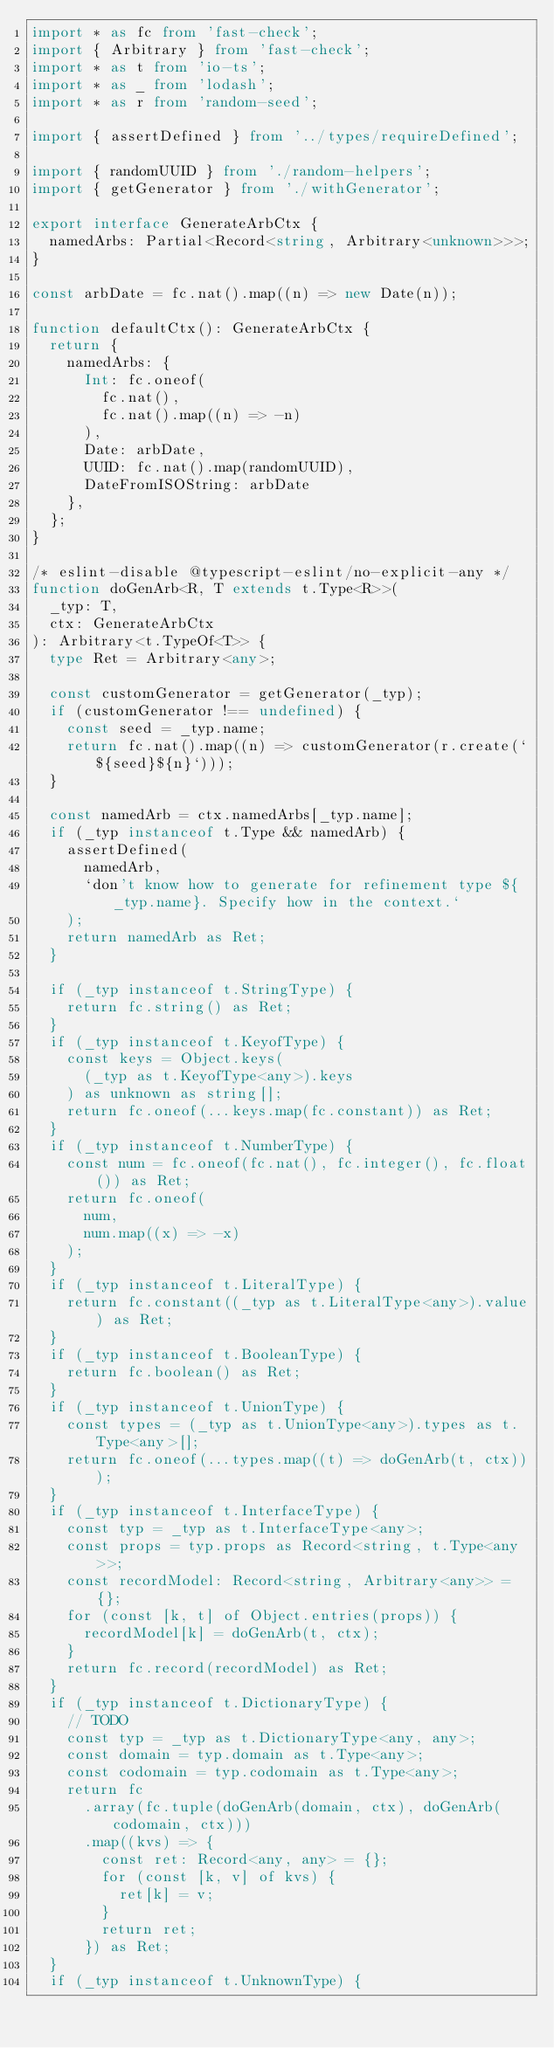Convert code to text. <code><loc_0><loc_0><loc_500><loc_500><_TypeScript_>import * as fc from 'fast-check';
import { Arbitrary } from 'fast-check';
import * as t from 'io-ts';
import * as _ from 'lodash';
import * as r from 'random-seed';

import { assertDefined } from '../types/requireDefined';

import { randomUUID } from './random-helpers';
import { getGenerator } from './withGenerator';

export interface GenerateArbCtx {
  namedArbs: Partial<Record<string, Arbitrary<unknown>>>;
}

const arbDate = fc.nat().map((n) => new Date(n));

function defaultCtx(): GenerateArbCtx {
  return {
    namedArbs: {
      Int: fc.oneof(
        fc.nat(),
        fc.nat().map((n) => -n)
      ),
      Date: arbDate,
      UUID: fc.nat().map(randomUUID),
      DateFromISOString: arbDate
    },
  };
}

/* eslint-disable @typescript-eslint/no-explicit-any */
function doGenArb<R, T extends t.Type<R>>(
  _typ: T,
  ctx: GenerateArbCtx
): Arbitrary<t.TypeOf<T>> {
  type Ret = Arbitrary<any>;

  const customGenerator = getGenerator(_typ);
  if (customGenerator !== undefined) {
    const seed = _typ.name;
    return fc.nat().map((n) => customGenerator(r.create(`${seed}${n}`)));
  }

  const namedArb = ctx.namedArbs[_typ.name];
  if (_typ instanceof t.Type && namedArb) {
    assertDefined(
      namedArb,
      `don't know how to generate for refinement type ${_typ.name}. Specify how in the context.`
    );
    return namedArb as Ret;
  }

  if (_typ instanceof t.StringType) {
    return fc.string() as Ret;
  }
  if (_typ instanceof t.KeyofType) {
    const keys = Object.keys(
      (_typ as t.KeyofType<any>).keys
    ) as unknown as string[];
    return fc.oneof(...keys.map(fc.constant)) as Ret;
  }
  if (_typ instanceof t.NumberType) {
    const num = fc.oneof(fc.nat(), fc.integer(), fc.float()) as Ret;
    return fc.oneof(
      num,
      num.map((x) => -x)
    );
  }
  if (_typ instanceof t.LiteralType) {
    return fc.constant((_typ as t.LiteralType<any>).value) as Ret;
  }
  if (_typ instanceof t.BooleanType) {
    return fc.boolean() as Ret;
  }
  if (_typ instanceof t.UnionType) {
    const types = (_typ as t.UnionType<any>).types as t.Type<any>[];
    return fc.oneof(...types.map((t) => doGenArb(t, ctx)));
  }
  if (_typ instanceof t.InterfaceType) {
    const typ = _typ as t.InterfaceType<any>;
    const props = typ.props as Record<string, t.Type<any>>;
    const recordModel: Record<string, Arbitrary<any>> = {};
    for (const [k, t] of Object.entries(props)) {
      recordModel[k] = doGenArb(t, ctx);
    }
    return fc.record(recordModel) as Ret;
  }
  if (_typ instanceof t.DictionaryType) {
    // TODO
    const typ = _typ as t.DictionaryType<any, any>;
    const domain = typ.domain as t.Type<any>;
    const codomain = typ.codomain as t.Type<any>;
    return fc
      .array(fc.tuple(doGenArb(domain, ctx), doGenArb(codomain, ctx)))
      .map((kvs) => {
        const ret: Record<any, any> = {};
        for (const [k, v] of kvs) {
          ret[k] = v;
        }
        return ret;
      }) as Ret;
  }
  if (_typ instanceof t.UnknownType) {</code> 